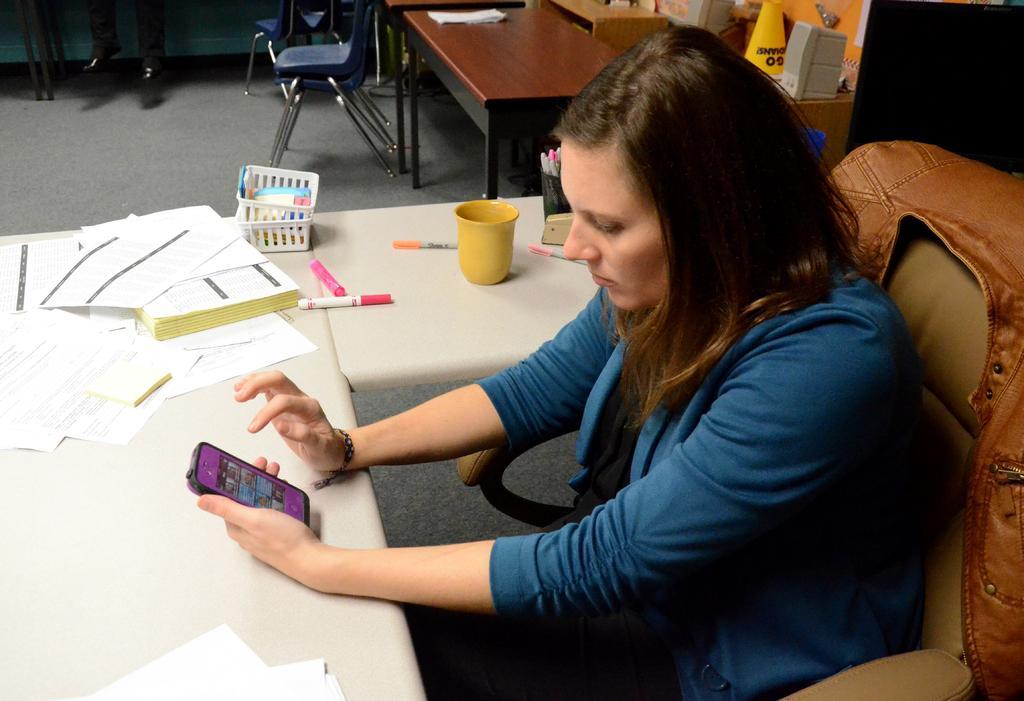How would you summarize this image in a sentence or two? In the picture we can see a woman sitting on the chair near the desk and holding a mobile phone. On the desk we can find a cup, pens, papers, aside to that desk we can see some tables and chairs. 